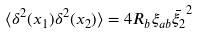<formula> <loc_0><loc_0><loc_500><loc_500>\langle \delta ^ { 2 } ( { x } _ { 1 } ) \delta ^ { 2 } ( { x } _ { 2 } ) \rangle = 4 R _ { b } \xi _ { a b } \bar { \xi _ { 2 } } ^ { 2 }</formula> 